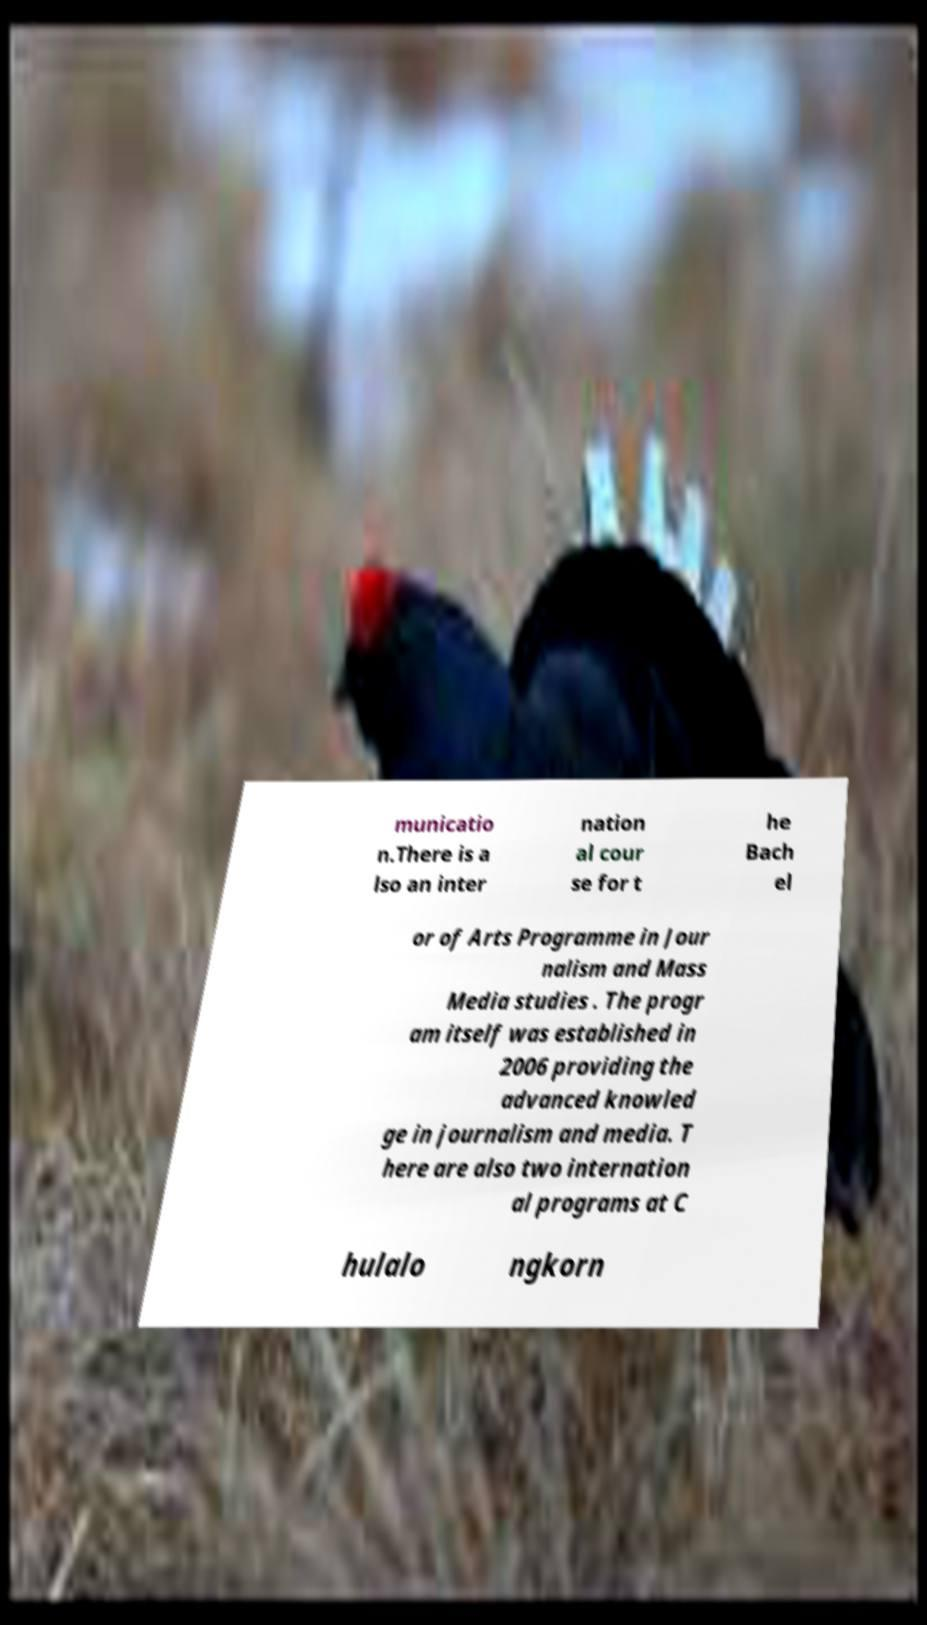Can you accurately transcribe the text from the provided image for me? municatio n.There is a lso an inter nation al cour se for t he Bach el or of Arts Programme in Jour nalism and Mass Media studies . The progr am itself was established in 2006 providing the advanced knowled ge in journalism and media. T here are also two internation al programs at C hulalo ngkorn 